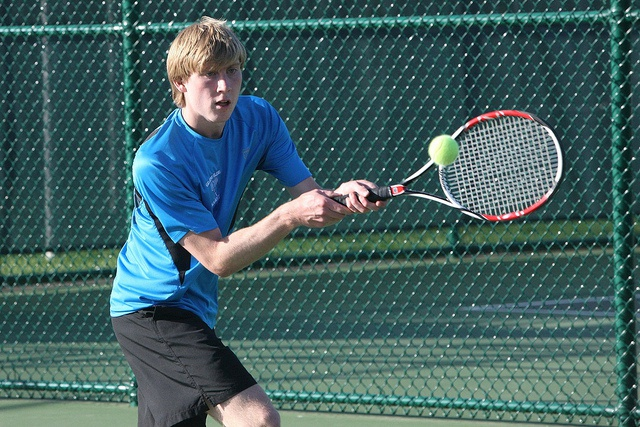Describe the objects in this image and their specific colors. I can see people in teal, gray, blue, black, and navy tones, tennis racket in teal, darkgray, lightgray, gray, and black tones, and sports ball in teal, lightyellow, lightgreen, and khaki tones in this image. 